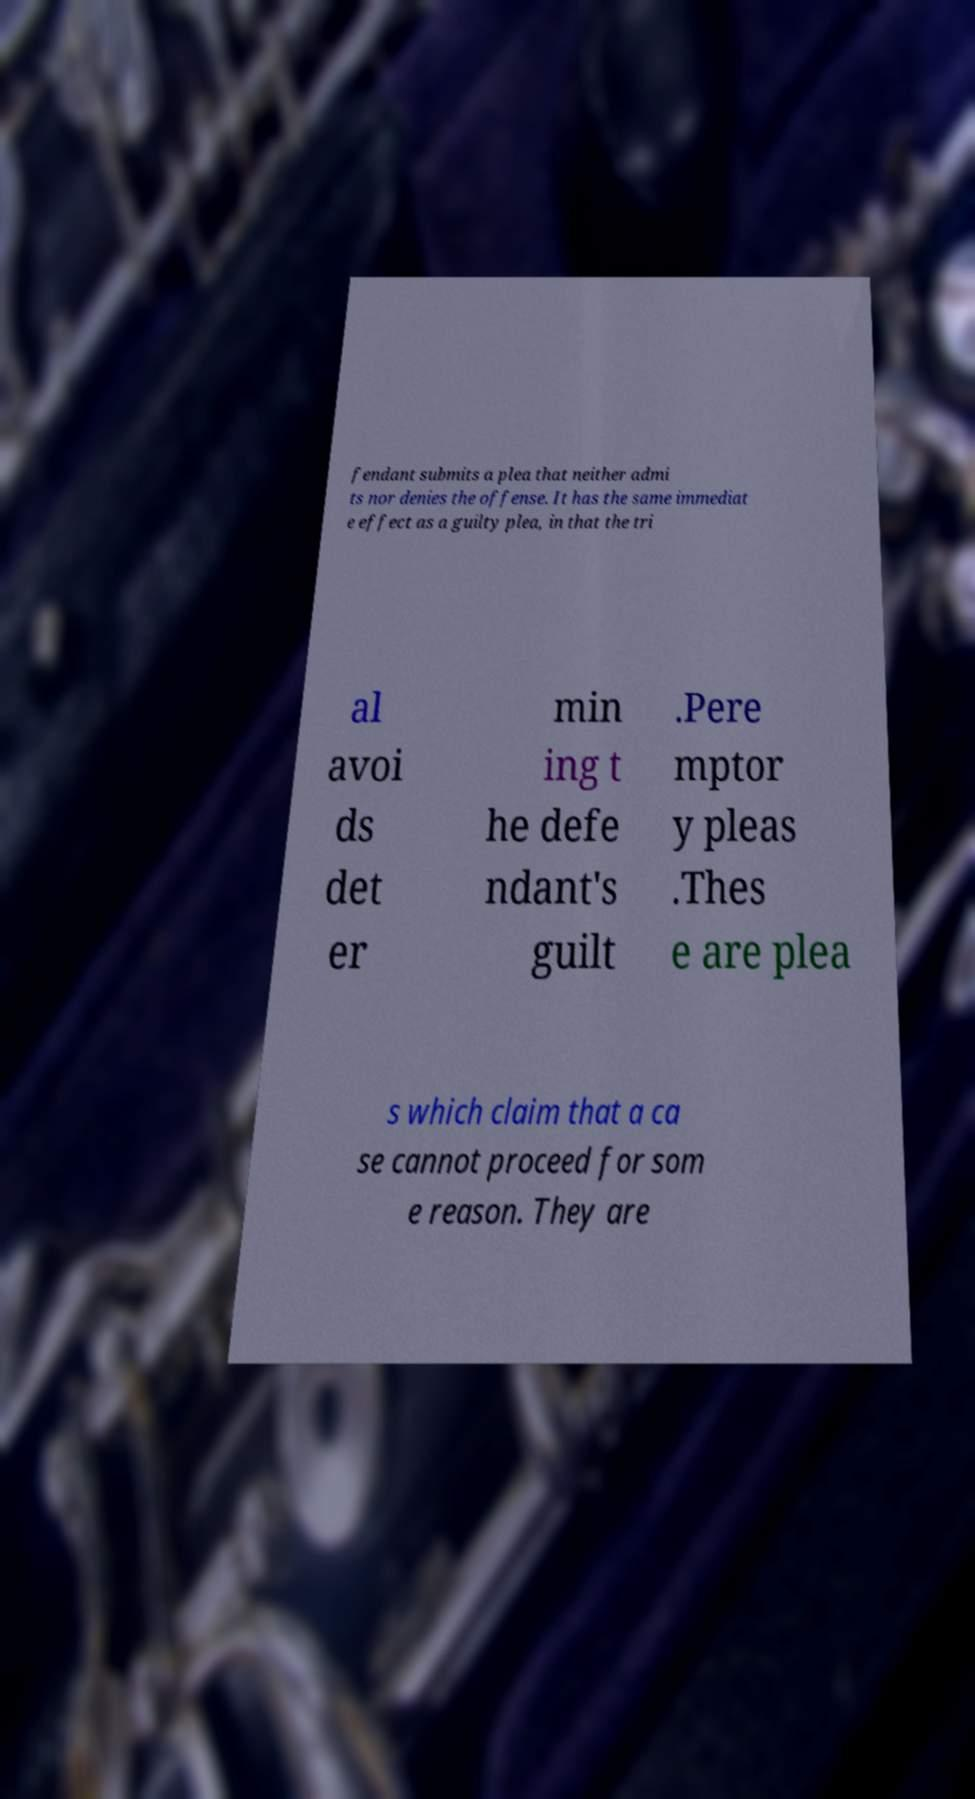Please identify and transcribe the text found in this image. fendant submits a plea that neither admi ts nor denies the offense. It has the same immediat e effect as a guilty plea, in that the tri al avoi ds det er min ing t he defe ndant's guilt .Pere mptor y pleas .Thes e are plea s which claim that a ca se cannot proceed for som e reason. They are 